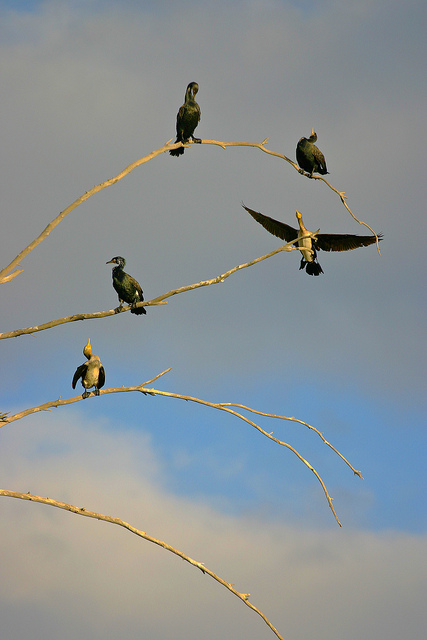How many birds are there?
Answer the question using a single word or phrase. 5 How many of the birds have their wings spread wide open? 1 Are these birds of the same specie? No 